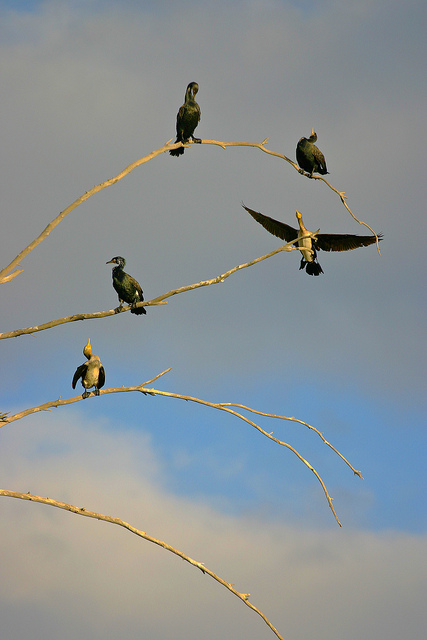How many birds are there?
Answer the question using a single word or phrase. 5 How many of the birds have their wings spread wide open? 1 Are these birds of the same specie? No 